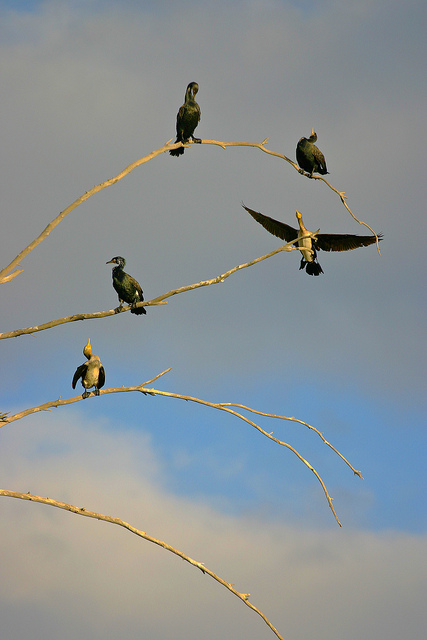How many birds are there?
Answer the question using a single word or phrase. 5 How many of the birds have their wings spread wide open? 1 Are these birds of the same specie? No 